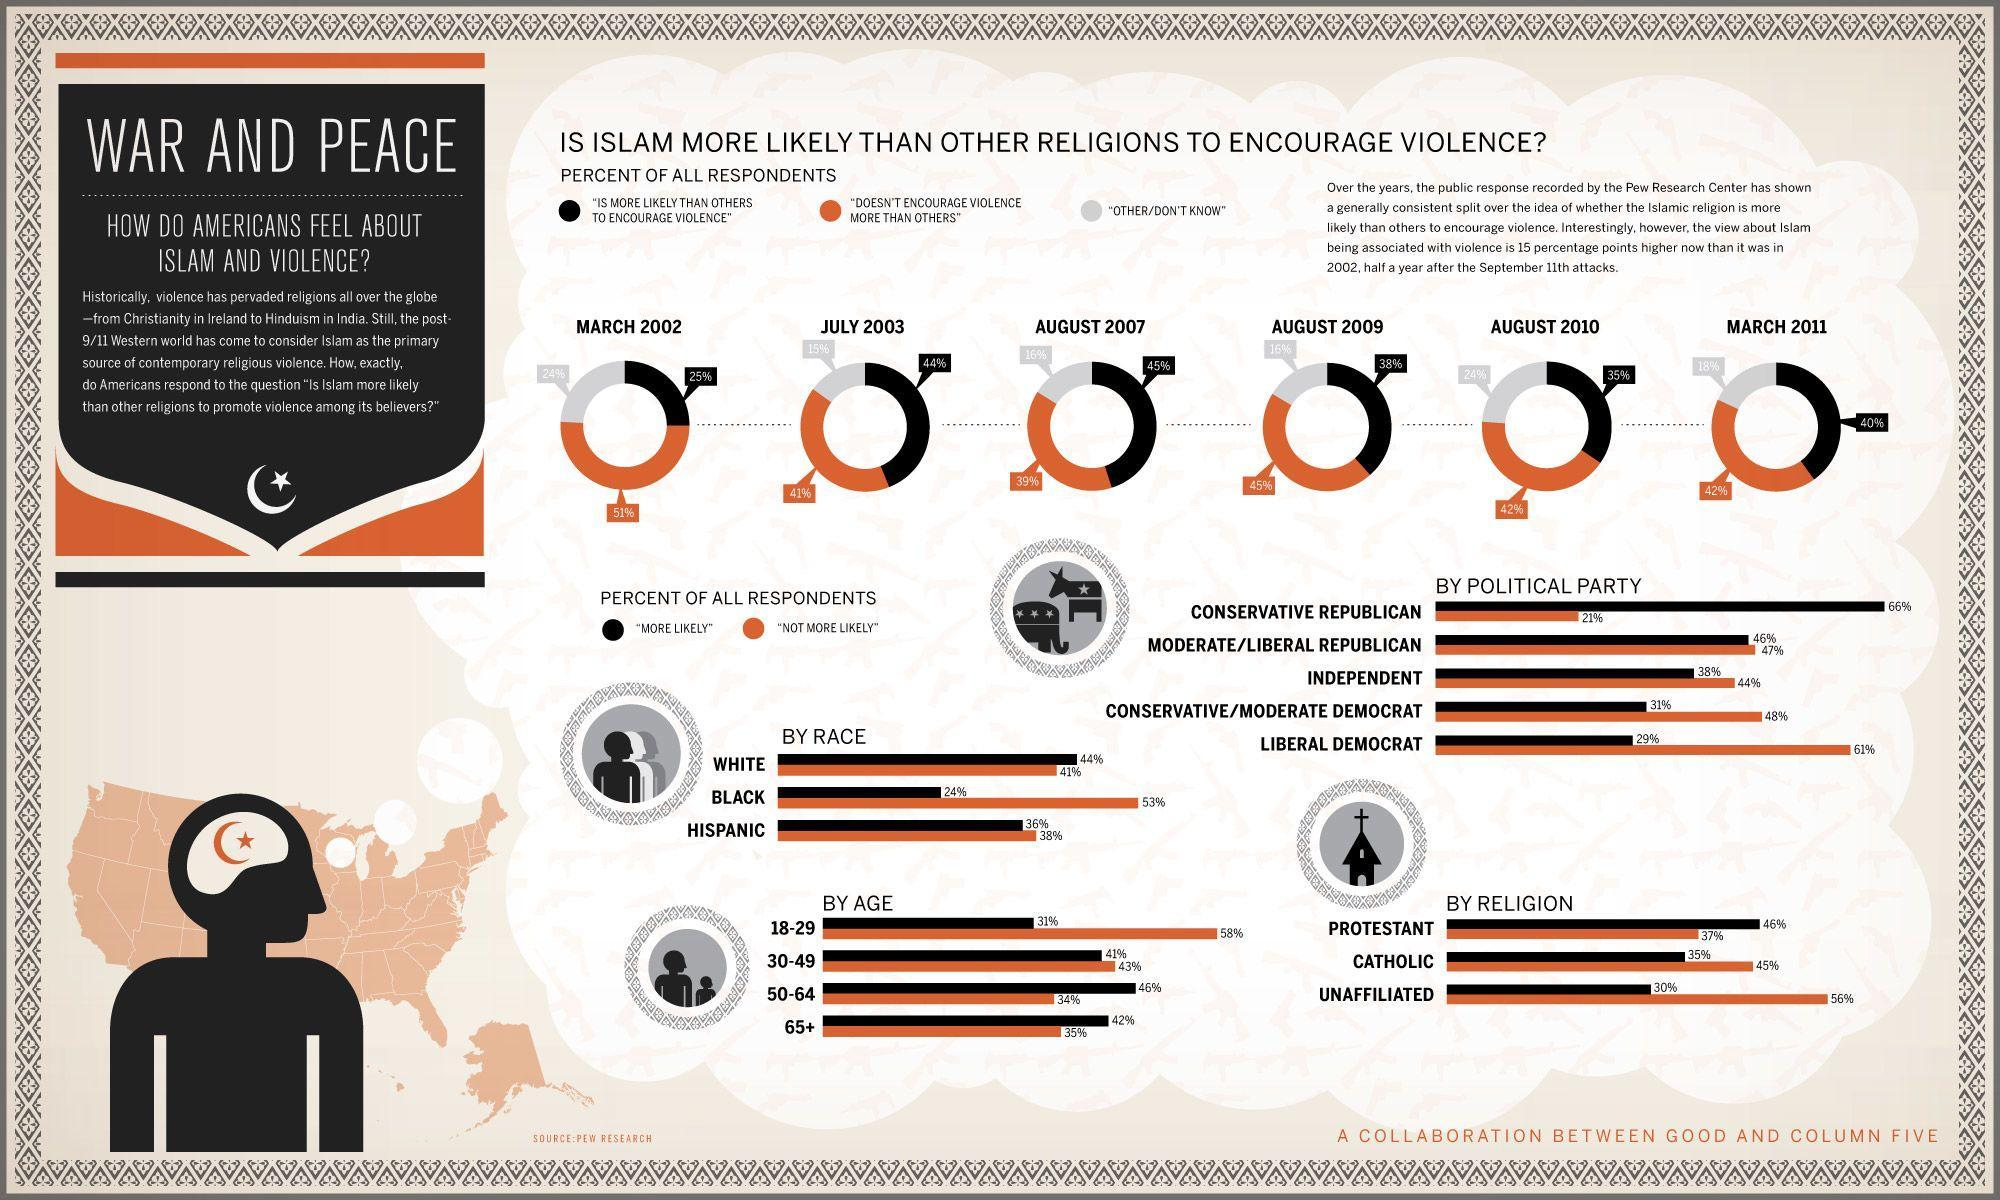what percent of people responded that Islam is more likely than others to encourage violence according to August 2010 survey?
Answer the question with a short phrase. 35% What percent of conservative republicans responded "more likely" to the question? 66% What percent of independents responded "not more likely" to the question? 44 What percent of conservative/moderate democrats responded "not more likely" to the question? 48% What percent of black people responded "more likely" to the question? 24 what percent of people responded that Islam doesn't encourage violence more than others according to August 2009 survey? 45 what percent of people responded that Islam is more likely than others to encourage violence according to march 2002 survey? 25 What percent of white people responded "not more likely" to the question? 41% What percent of liberal/moderate republicans responded "more likely" to the question? 46 what percent of people responded that Islam doesn't encourage violence more than others according to March 2011 survey? 42 What percent of catholic people responded "more likely" to the question? 35% What percent of Hispanic people responded "more likely" to the question? 36% what percent of people responded that Islam is more likely than others to encourage violence according to August 2007 survey? 45 What percent of liberal democrats responded "not more likely" to the question? 61% what percent of people responded that Islam doesn't encourage violence more than others according to July 2003 survey? 41% 